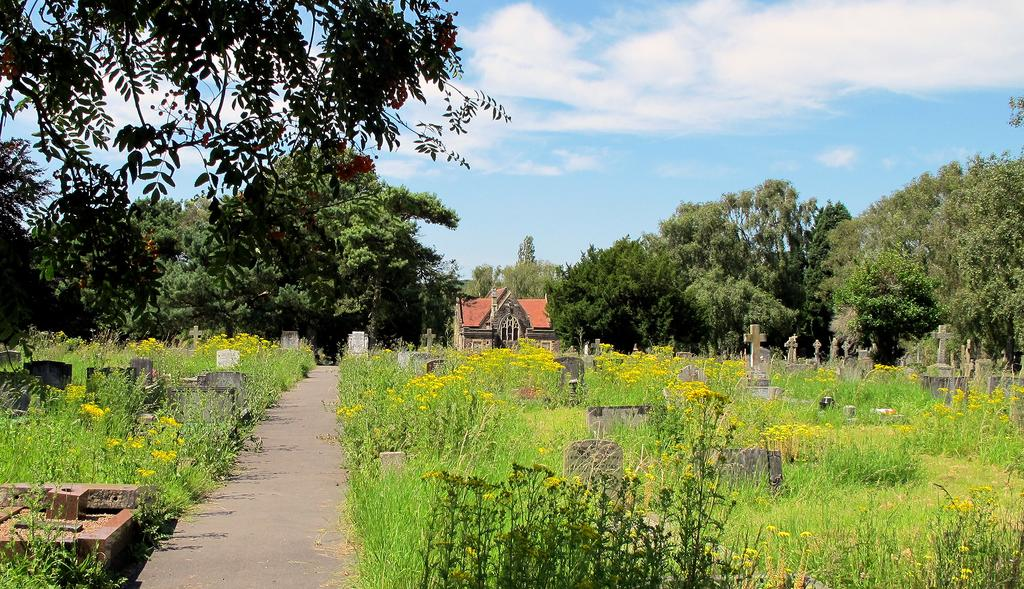What type of structures can be seen in the image? There are gravestones in the image. What other elements can be found in the image? There are plants, a road, and a building in the background of the image. What can be seen in the distance in the image? There are trees and the sky visible in the background of the image. How much dust is present on the gravestones in the image? There is no information about dust on the gravestones in the image, so it cannot be determined. Can you tell me what the grandfather of the person who took the image looks like? There is no information about the person who took the image or their family members in the image, so it cannot be determined. 